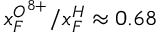<formula> <loc_0><loc_0><loc_500><loc_500>x _ { F } ^ { O ^ { 8 + } } / x _ { F } ^ { H } \approx 0 . 6 8</formula> 